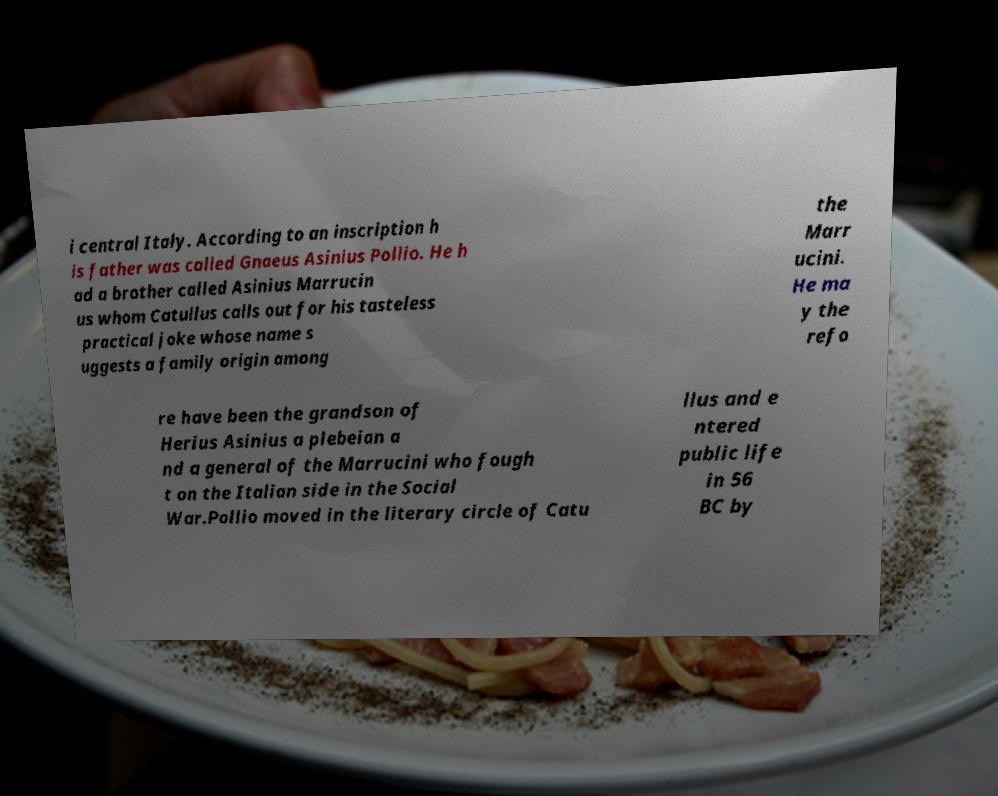What messages or text are displayed in this image? I need them in a readable, typed format. i central Italy. According to an inscription h is father was called Gnaeus Asinius Pollio. He h ad a brother called Asinius Marrucin us whom Catullus calls out for his tasteless practical joke whose name s uggests a family origin among the Marr ucini. He ma y the refo re have been the grandson of Herius Asinius a plebeian a nd a general of the Marrucini who fough t on the Italian side in the Social War.Pollio moved in the literary circle of Catu llus and e ntered public life in 56 BC by 